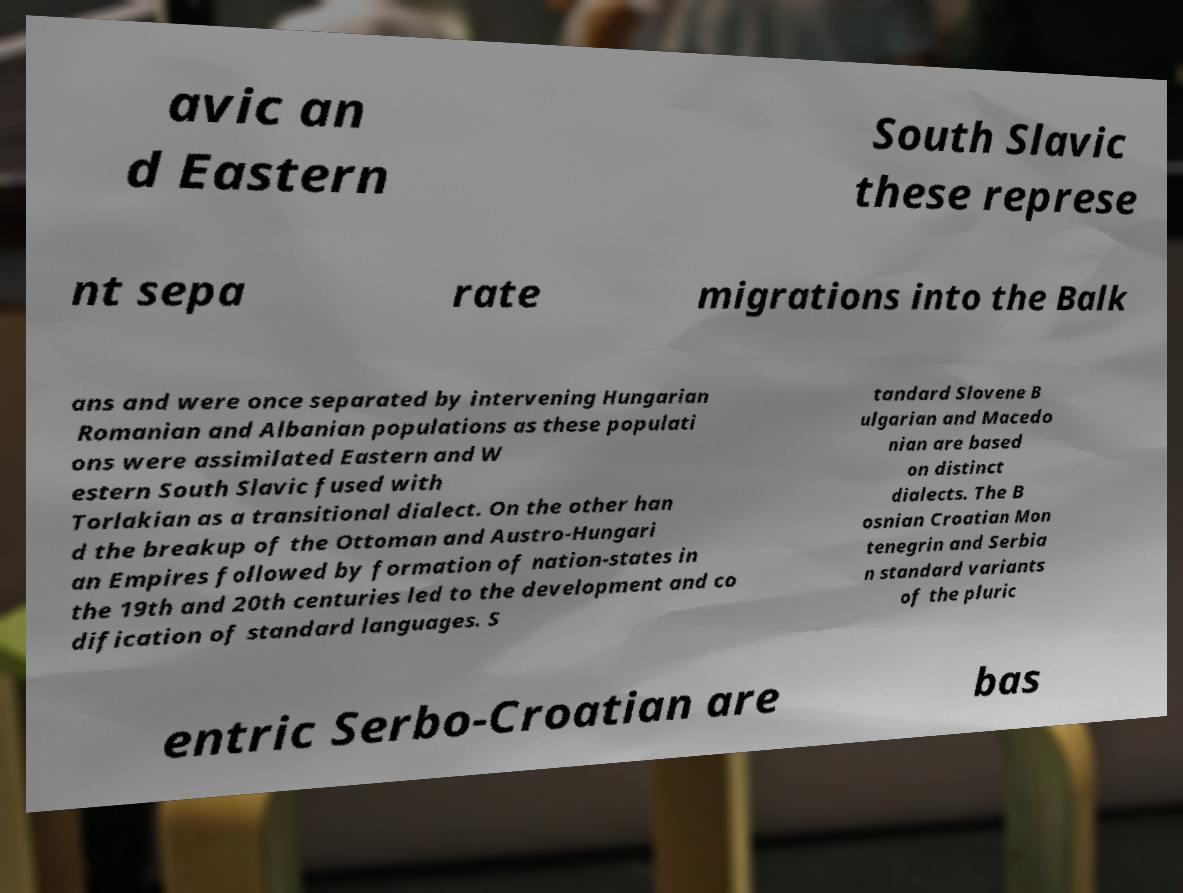What messages or text are displayed in this image? I need them in a readable, typed format. avic an d Eastern South Slavic these represe nt sepa rate migrations into the Balk ans and were once separated by intervening Hungarian Romanian and Albanian populations as these populati ons were assimilated Eastern and W estern South Slavic fused with Torlakian as a transitional dialect. On the other han d the breakup of the Ottoman and Austro-Hungari an Empires followed by formation of nation-states in the 19th and 20th centuries led to the development and co dification of standard languages. S tandard Slovene B ulgarian and Macedo nian are based on distinct dialects. The B osnian Croatian Mon tenegrin and Serbia n standard variants of the pluric entric Serbo-Croatian are bas 